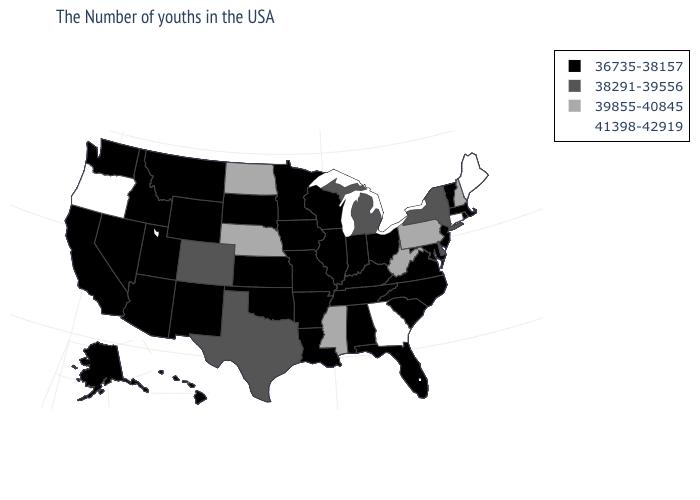Which states hav the highest value in the Northeast?
Concise answer only. Maine, Connecticut. Which states have the lowest value in the USA?
Concise answer only. Massachusetts, Rhode Island, Vermont, New Jersey, Maryland, Virginia, North Carolina, South Carolina, Ohio, Florida, Kentucky, Indiana, Alabama, Tennessee, Wisconsin, Illinois, Louisiana, Missouri, Arkansas, Minnesota, Iowa, Kansas, Oklahoma, South Dakota, Wyoming, New Mexico, Utah, Montana, Arizona, Idaho, Nevada, California, Washington, Alaska, Hawaii. Name the states that have a value in the range 38291-39556?
Write a very short answer. New York, Delaware, Michigan, Texas, Colorado. What is the lowest value in the USA?
Concise answer only. 36735-38157. What is the highest value in the West ?
Quick response, please. 41398-42919. What is the value of Washington?
Answer briefly. 36735-38157. What is the highest value in the USA?
Keep it brief. 41398-42919. What is the lowest value in the USA?
Answer briefly. 36735-38157. What is the value of New Jersey?
Answer briefly. 36735-38157. Does Oregon have the highest value in the USA?
Give a very brief answer. Yes. Does Maryland have a lower value than Kansas?
Give a very brief answer. No. Does Alabama have the same value as Florida?
Answer briefly. Yes. Name the states that have a value in the range 41398-42919?
Concise answer only. Maine, Connecticut, Georgia, Oregon. Which states have the highest value in the USA?
Keep it brief. Maine, Connecticut, Georgia, Oregon. What is the value of Louisiana?
Quick response, please. 36735-38157. 